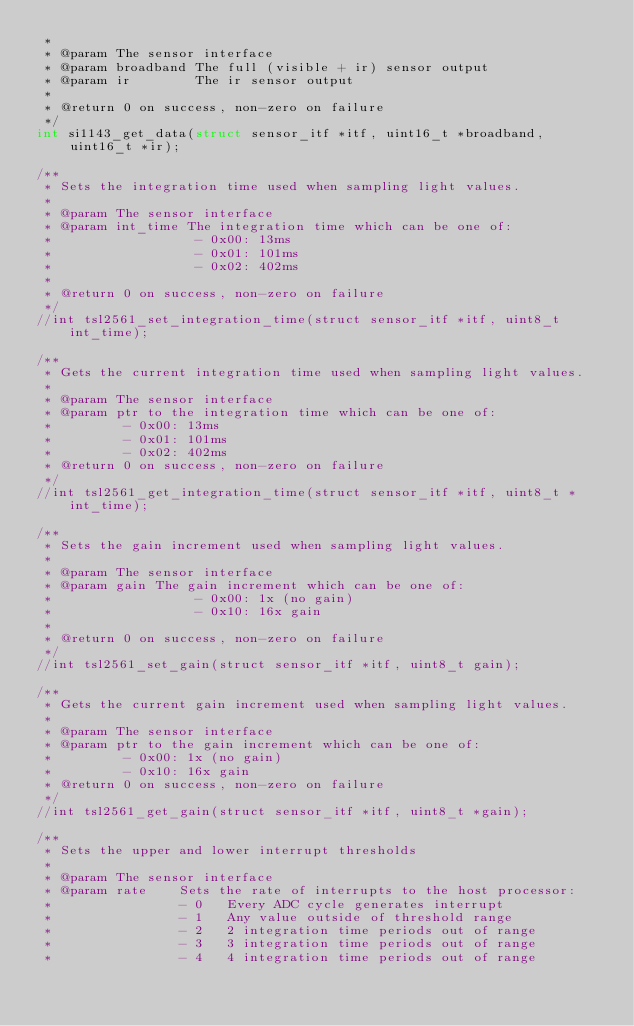Convert code to text. <code><loc_0><loc_0><loc_500><loc_500><_C_> *
 * @param The sensor interface
 * @param broadband The full (visible + ir) sensor output
 * @param ir        The ir sensor output
 *
 * @return 0 on success, non-zero on failure
 */
int si1143_get_data(struct sensor_itf *itf, uint16_t *broadband, uint16_t *ir);

/**
 * Sets the integration time used when sampling light values.
 *
 * @param The sensor interface
 * @param int_time The integration time which can be one of:
 *                  - 0x00: 13ms
 *                  - 0x01: 101ms
 *                  - 0x02: 402ms
 *
 * @return 0 on success, non-zero on failure
 */
//int tsl2561_set_integration_time(struct sensor_itf *itf, uint8_t int_time);

/**
 * Gets the current integration time used when sampling light values.
 *
 * @param The sensor interface
 * @param ptr to the integration time which can be one of:
 *         - 0x00: 13ms
 *         - 0x01: 101ms
 *         - 0x02: 402ms
 * @return 0 on success, non-zero on failure
 */
//int tsl2561_get_integration_time(struct sensor_itf *itf, uint8_t *int_time);

/**
 * Sets the gain increment used when sampling light values.
 *
 * @param The sensor interface
 * @param gain The gain increment which can be one of:
 *                  - 0x00: 1x (no gain)
 *                  - 0x10: 16x gain
 *
 * @return 0 on success, non-zero on failure
 */
//int tsl2561_set_gain(struct sensor_itf *itf, uint8_t gain);

/**
 * Gets the current gain increment used when sampling light values.
 *
 * @param The sensor interface
 * @param ptr to the gain increment which can be one of:
 *         - 0x00: 1x (no gain)
 *         - 0x10: 16x gain
 * @return 0 on success, non-zero on failure
 */
//int tsl2561_get_gain(struct sensor_itf *itf, uint8_t *gain);

/**
 * Sets the upper and lower interrupt thresholds
 *
 * @param The sensor interface
 * @param rate    Sets the rate of interrupts to the host processor:
 *                - 0   Every ADC cycle generates interrupt
 *                - 1   Any value outside of threshold range
 *                - 2   2 integration time periods out of range
 *                - 3   3 integration time periods out of range
 *                - 4   4 integration time periods out of range</code> 